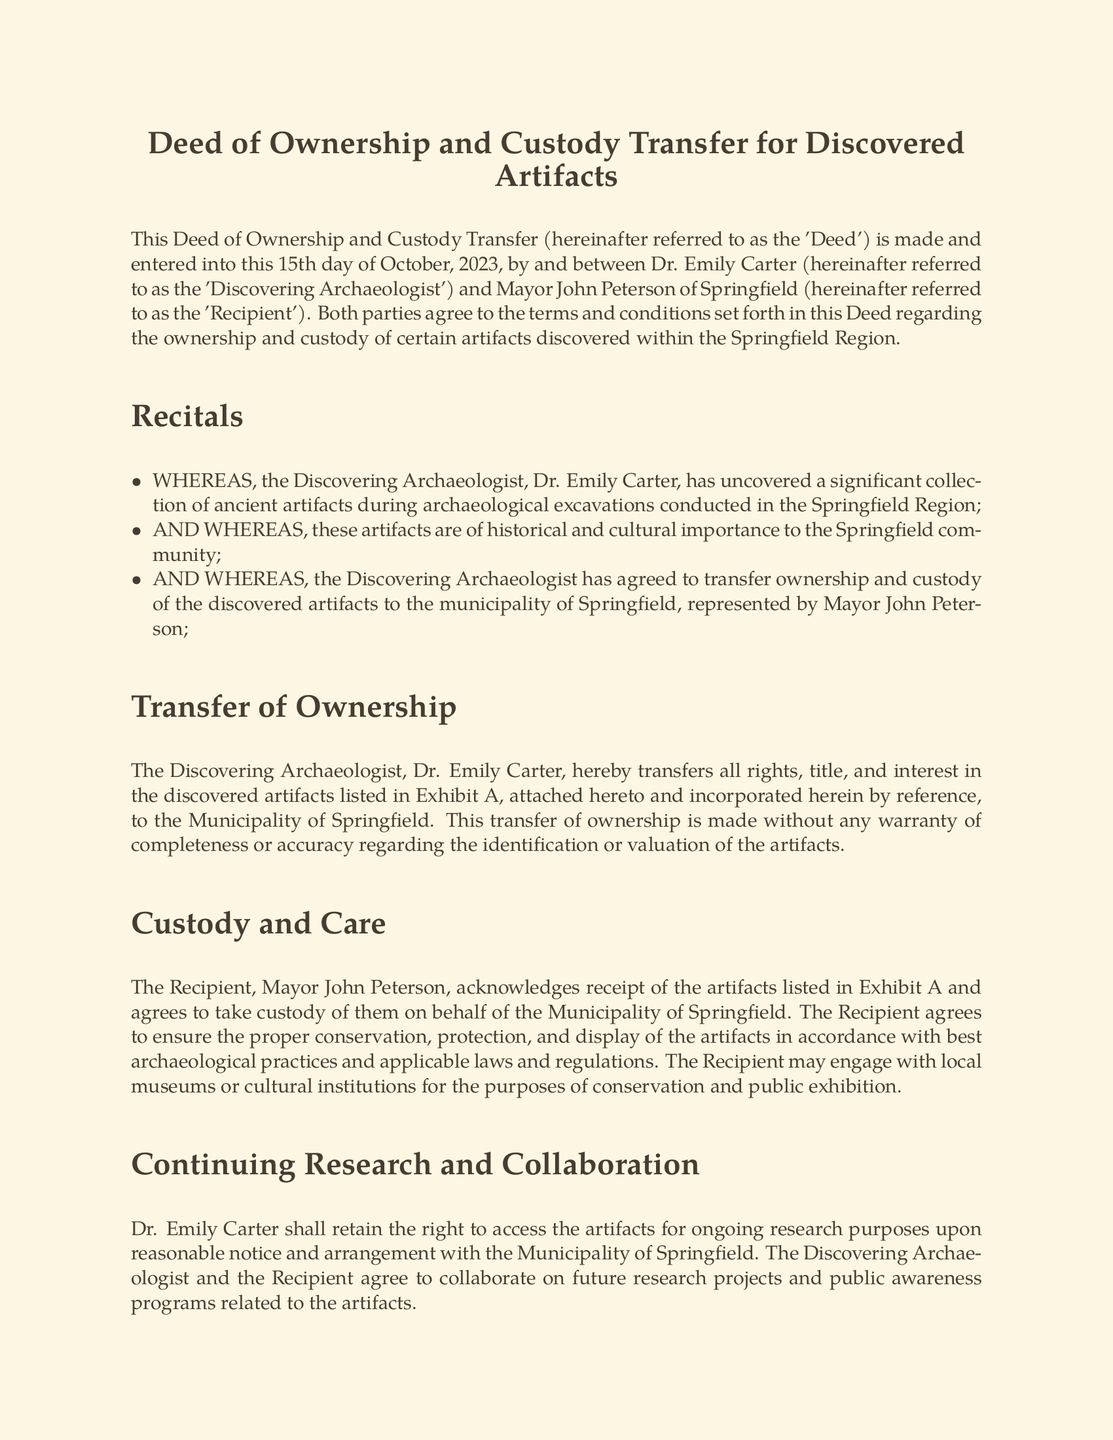What is the date of the deed? The date of the deed is specified at the beginning of the document, which is the 15th day of October, 2023.
Answer: 15th day of October, 2023 Who is the Discovering Archaeologist? The Discovering Archaeologist is named in the opening section of the document as Dr. Emily Carter.
Answer: Dr. Emily Carter Who is the Recipient of the artifacts? The Recipient is identified as Mayor John Peterson of Springfield in the preliminary section of the document.
Answer: Mayor John Peterson What is the first artifact listed in Exhibit A? The first artifact noted in Exhibit A is "Ancient pottery shards from the 3rd century BC."
Answer: Ancient pottery shards from the 3rd century BC What rights are retained by Dr. Emily Carter? Dr. Emily Carter retains the right to access the artifacts for ongoing research purposes.
Answer: Right to access the artifacts for ongoing research purposes What is the governing law for this deed? The document specifies that the deed shall be governed by and construed in accordance with the laws of the State of Illinois.
Answer: State of Illinois What type of artifacts are included in this deed? The artifacts mentioned are described as ancient and of historical and cultural importance to the Springfield community.
Answer: Ancient artifacts of historical and cultural importance What is the purpose of the custody agreement? The custody agreement ensures the proper conservation, protection, and display of the artifacts according to best archaeological practices.
Answer: Ensure proper conservation, protection, and display What is required for amendments to this deed? Amendments to this deed must be in writing and signed by both parties as stated in the miscellaneous provisions.
Answer: In writing and signed by both parties 